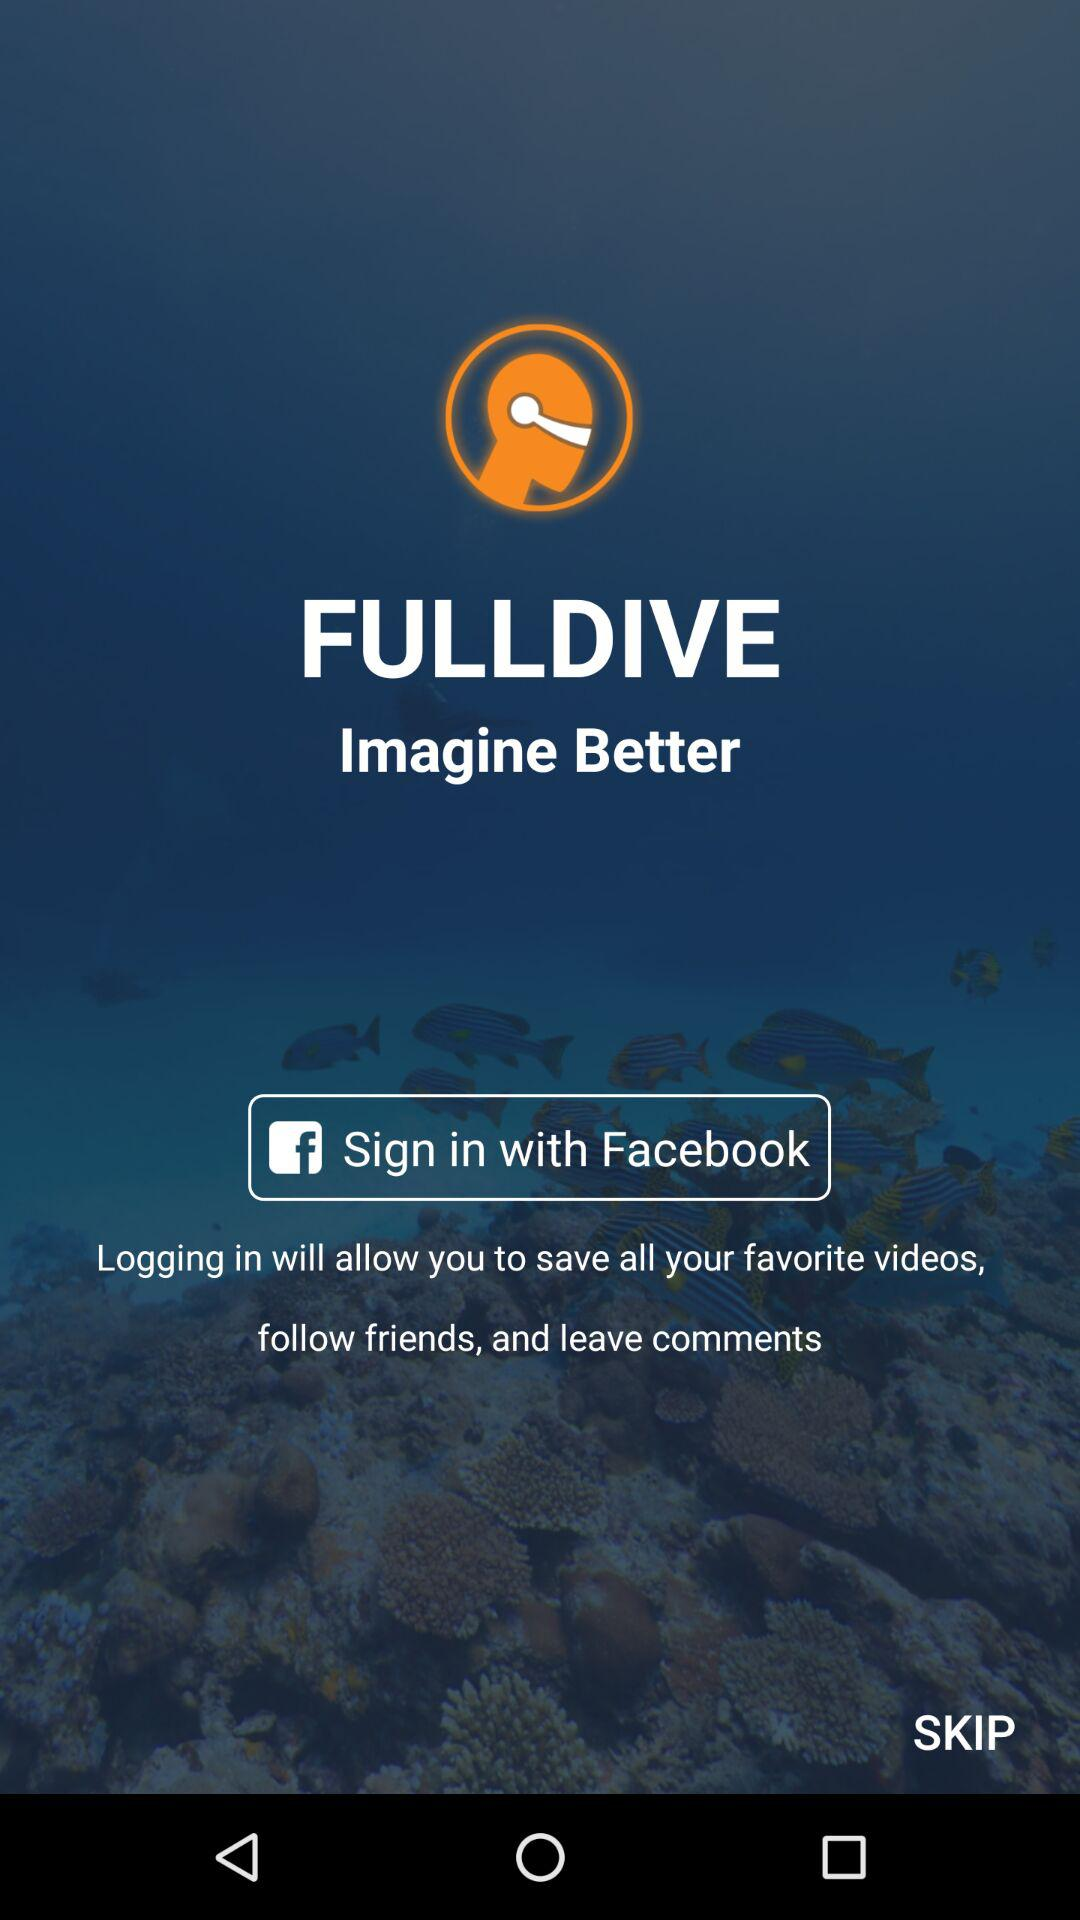What social media can we use to log in? You can use "Facebook" to log in. 